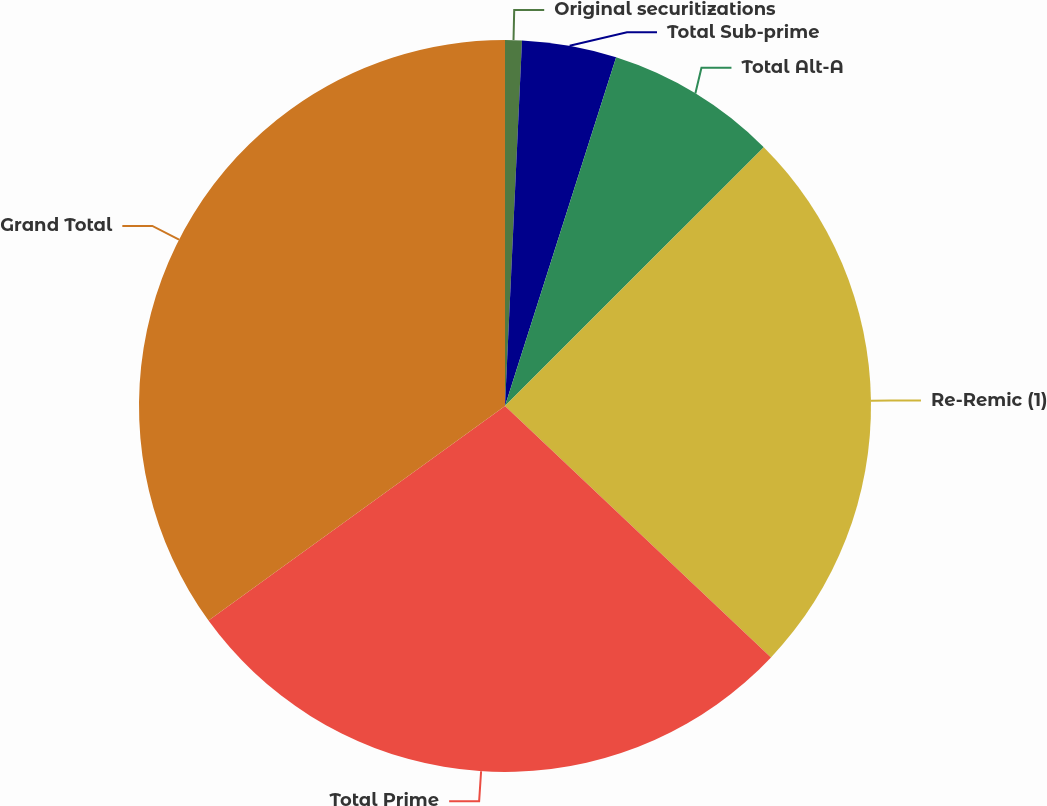Convert chart. <chart><loc_0><loc_0><loc_500><loc_500><pie_chart><fcel>Original securitizations<fcel>Total Sub-prime<fcel>Total Alt-A<fcel>Re-Remic (1)<fcel>Total Prime<fcel>Grand Total<nl><fcel>0.74%<fcel>4.17%<fcel>7.59%<fcel>24.55%<fcel>27.98%<fcel>34.97%<nl></chart> 